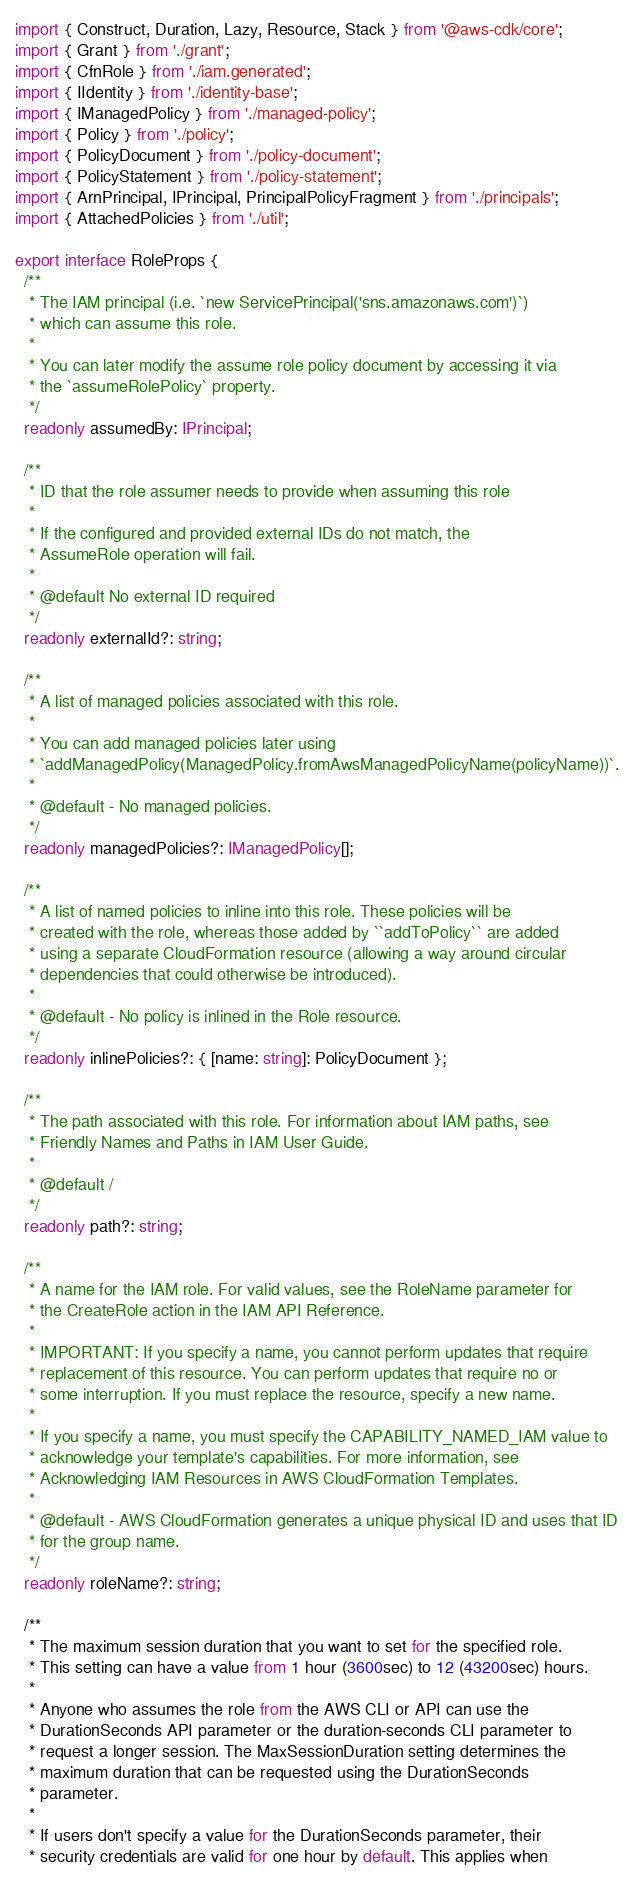Convert code to text. <code><loc_0><loc_0><loc_500><loc_500><_TypeScript_>import { Construct, Duration, Lazy, Resource, Stack } from '@aws-cdk/core';
import { Grant } from './grant';
import { CfnRole } from './iam.generated';
import { IIdentity } from './identity-base';
import { IManagedPolicy } from './managed-policy';
import { Policy } from './policy';
import { PolicyDocument } from './policy-document';
import { PolicyStatement } from './policy-statement';
import { ArnPrincipal, IPrincipal, PrincipalPolicyFragment } from './principals';
import { AttachedPolicies } from './util';

export interface RoleProps {
  /**
   * The IAM principal (i.e. `new ServicePrincipal('sns.amazonaws.com')`)
   * which can assume this role.
   *
   * You can later modify the assume role policy document by accessing it via
   * the `assumeRolePolicy` property.
   */
  readonly assumedBy: IPrincipal;

  /**
   * ID that the role assumer needs to provide when assuming this role
   *
   * If the configured and provided external IDs do not match, the
   * AssumeRole operation will fail.
   *
   * @default No external ID required
   */
  readonly externalId?: string;

  /**
   * A list of managed policies associated with this role.
   *
   * You can add managed policies later using
   * `addManagedPolicy(ManagedPolicy.fromAwsManagedPolicyName(policyName))`.
   *
   * @default - No managed policies.
   */
  readonly managedPolicies?: IManagedPolicy[];

  /**
   * A list of named policies to inline into this role. These policies will be
   * created with the role, whereas those added by ``addToPolicy`` are added
   * using a separate CloudFormation resource (allowing a way around circular
   * dependencies that could otherwise be introduced).
   *
   * @default - No policy is inlined in the Role resource.
   */
  readonly inlinePolicies?: { [name: string]: PolicyDocument };

  /**
   * The path associated with this role. For information about IAM paths, see
   * Friendly Names and Paths in IAM User Guide.
   *
   * @default /
   */
  readonly path?: string;

  /**
   * A name for the IAM role. For valid values, see the RoleName parameter for
   * the CreateRole action in the IAM API Reference.
   *
   * IMPORTANT: If you specify a name, you cannot perform updates that require
   * replacement of this resource. You can perform updates that require no or
   * some interruption. If you must replace the resource, specify a new name.
   *
   * If you specify a name, you must specify the CAPABILITY_NAMED_IAM value to
   * acknowledge your template's capabilities. For more information, see
   * Acknowledging IAM Resources in AWS CloudFormation Templates.
   *
   * @default - AWS CloudFormation generates a unique physical ID and uses that ID
   * for the group name.
   */
  readonly roleName?: string;

  /**
   * The maximum session duration that you want to set for the specified role.
   * This setting can have a value from 1 hour (3600sec) to 12 (43200sec) hours.
   *
   * Anyone who assumes the role from the AWS CLI or API can use the
   * DurationSeconds API parameter or the duration-seconds CLI parameter to
   * request a longer session. The MaxSessionDuration setting determines the
   * maximum duration that can be requested using the DurationSeconds
   * parameter.
   *
   * If users don't specify a value for the DurationSeconds parameter, their
   * security credentials are valid for one hour by default. This applies when</code> 